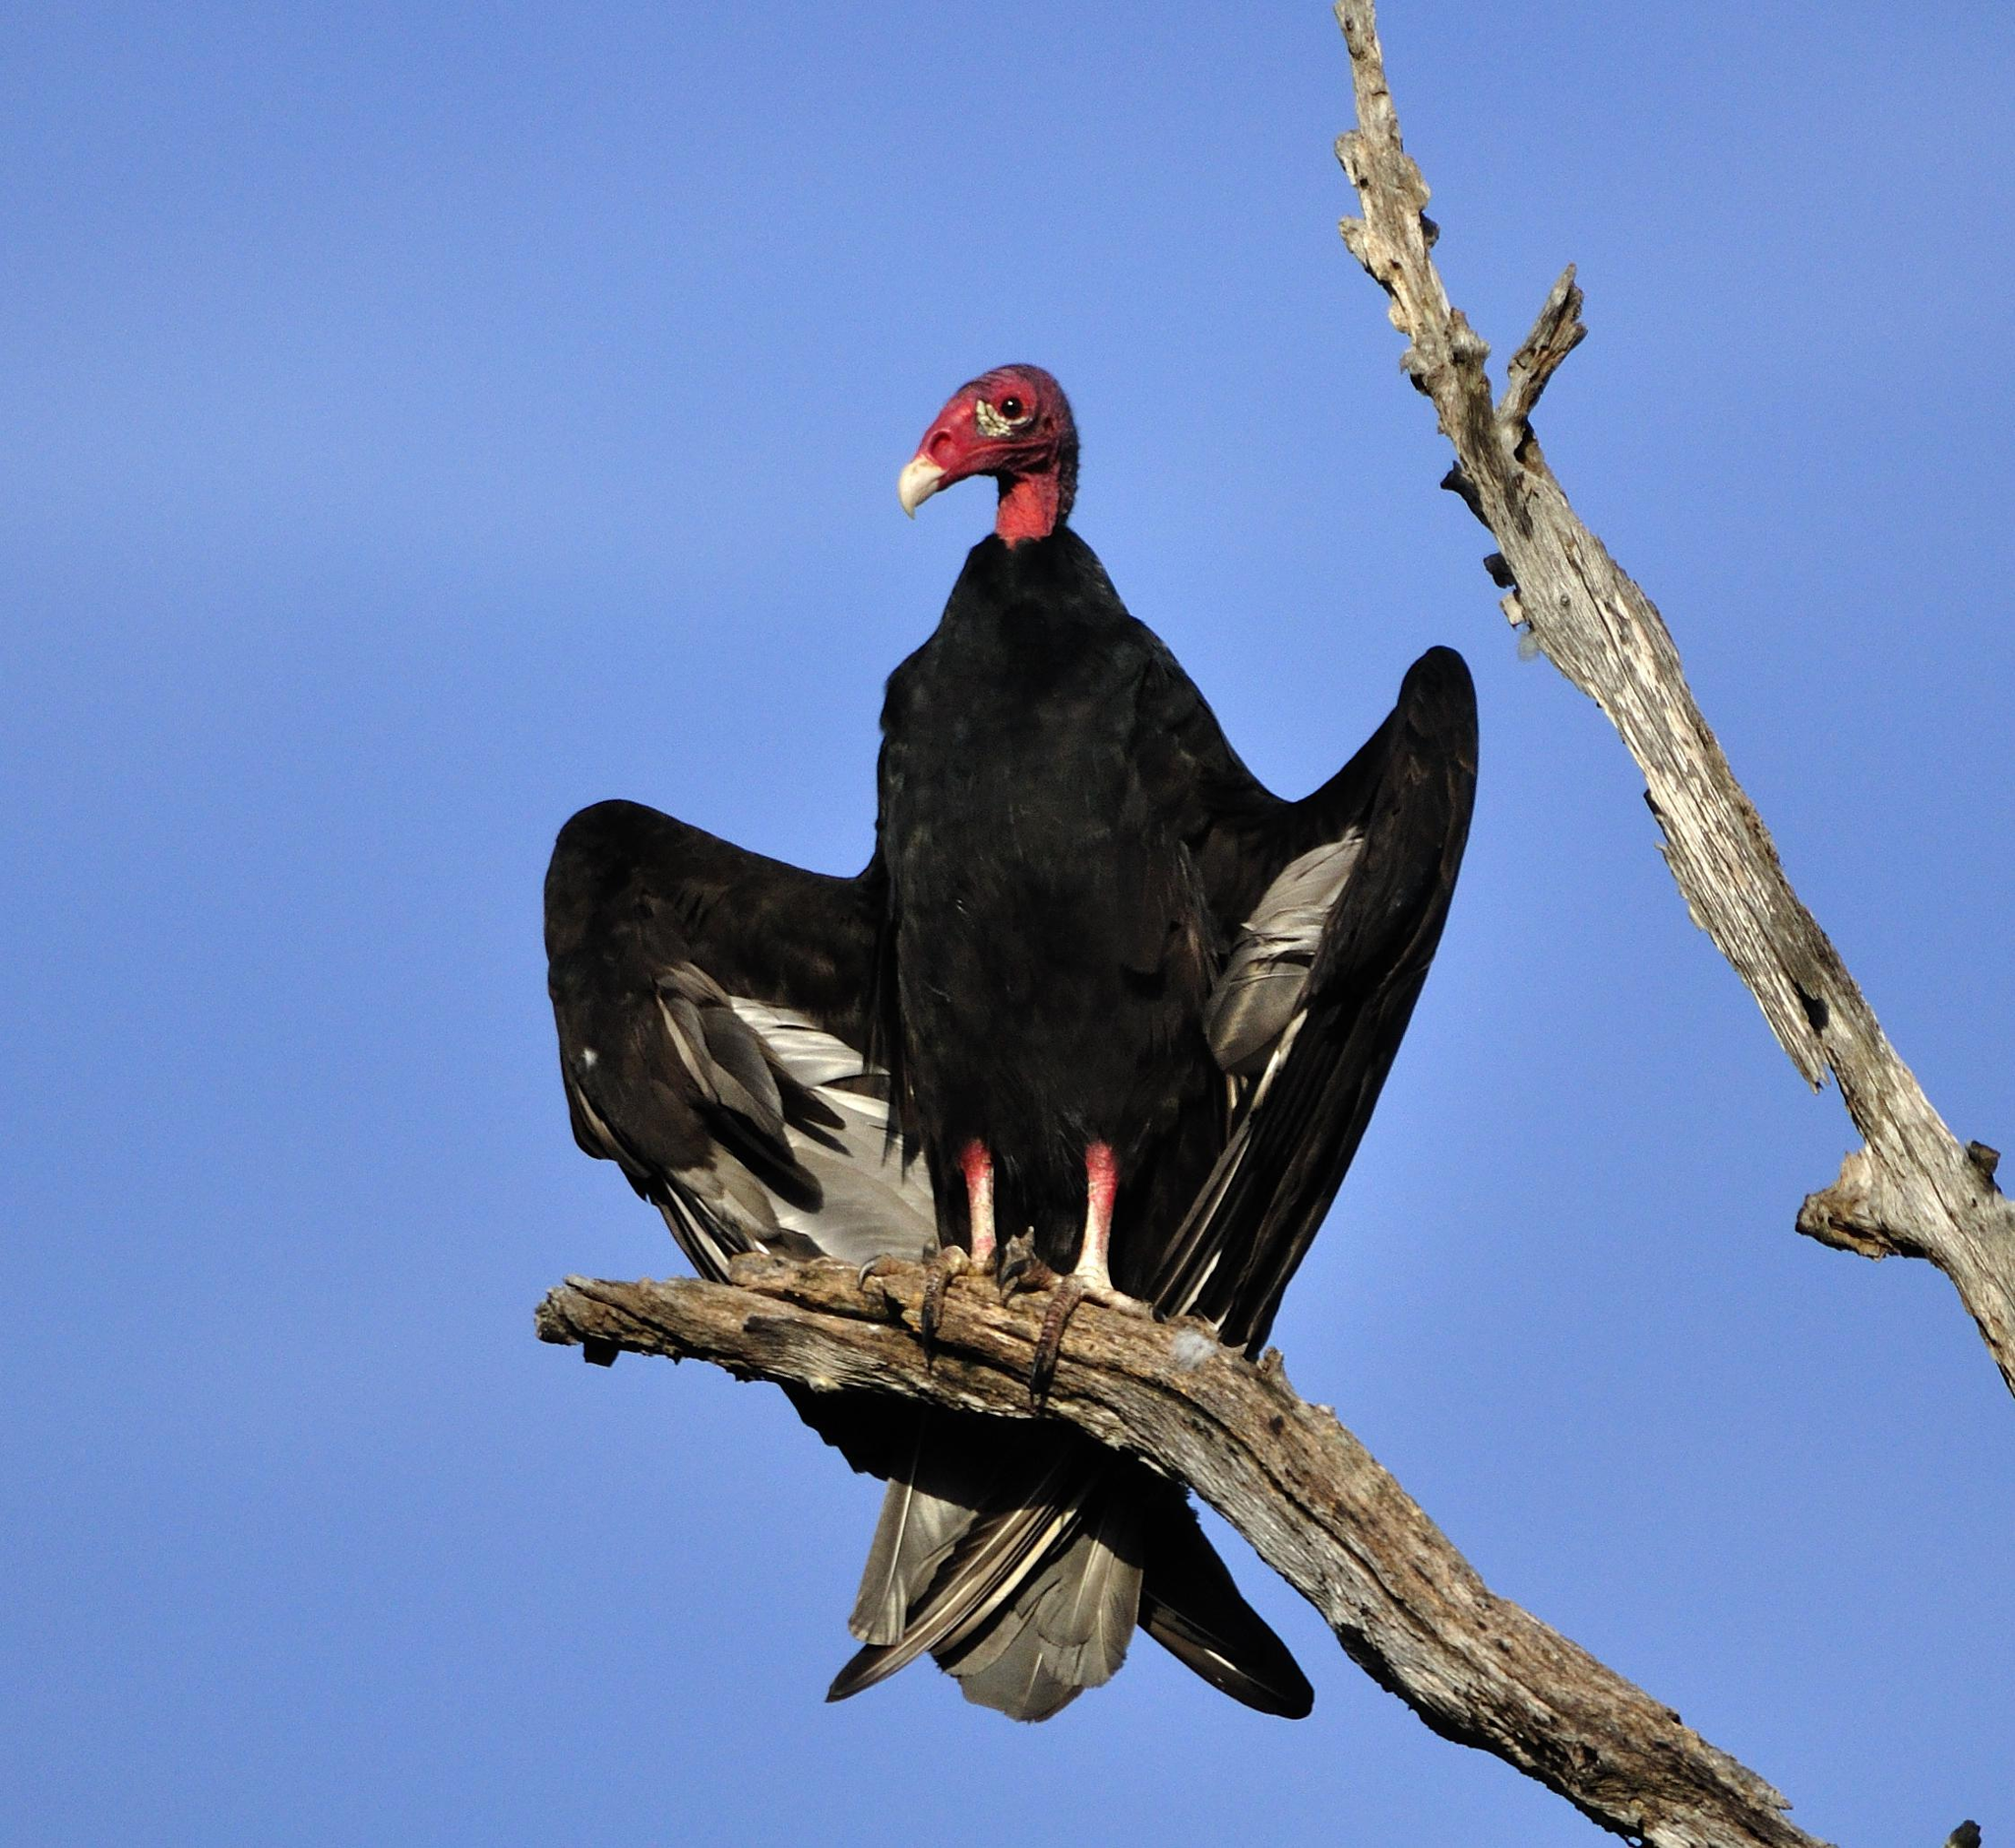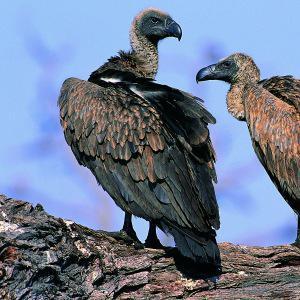The first image is the image on the left, the second image is the image on the right. Assess this claim about the two images: "There are three birds, two of which are facing left, and one of which is facing right.". Correct or not? Answer yes or no. Yes. The first image is the image on the left, the second image is the image on the right. Evaluate the accuracy of this statement regarding the images: "There is a bird in flight not touching the ground.". Is it true? Answer yes or no. No. 